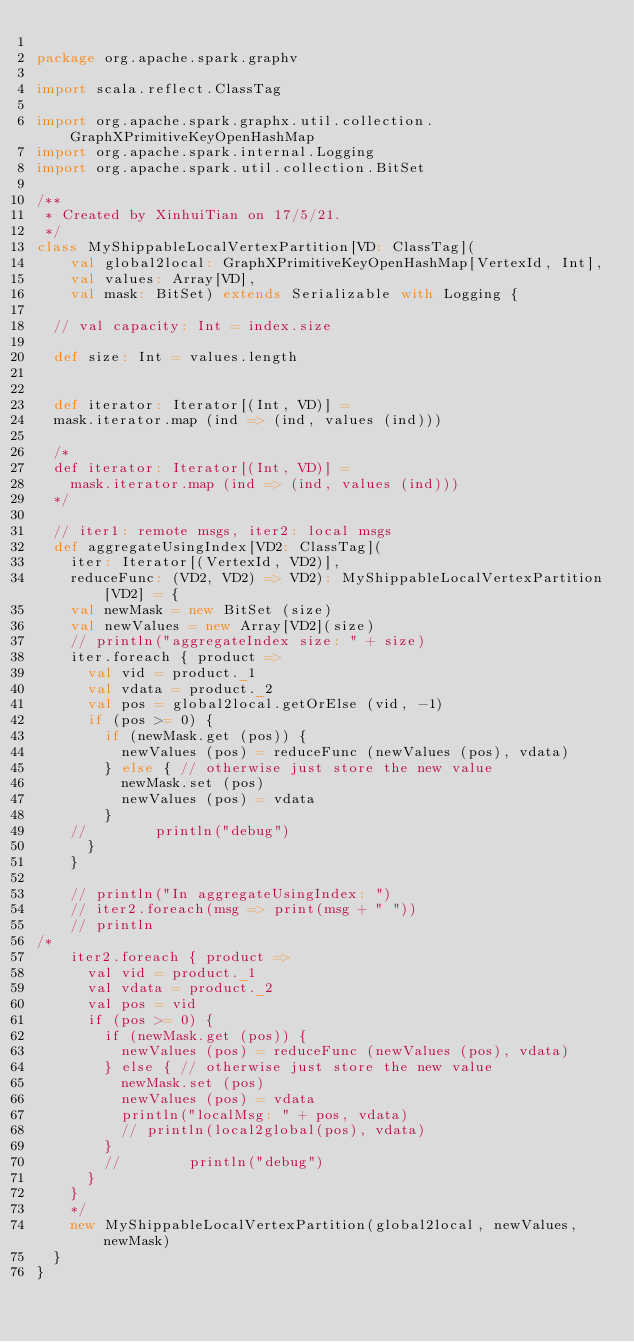Convert code to text. <code><loc_0><loc_0><loc_500><loc_500><_Scala_>
package org.apache.spark.graphv

import scala.reflect.ClassTag

import org.apache.spark.graphx.util.collection.GraphXPrimitiveKeyOpenHashMap
import org.apache.spark.internal.Logging
import org.apache.spark.util.collection.BitSet

/**
 * Created by XinhuiTian on 17/5/21.
 */
class MyShippableLocalVertexPartition[VD: ClassTag](
    val global2local: GraphXPrimitiveKeyOpenHashMap[VertexId, Int],
    val values: Array[VD],
    val mask: BitSet) extends Serializable with Logging {

  // val capacity: Int = index.size

  def size: Int = values.length


  def iterator: Iterator[(Int, VD)] =
  mask.iterator.map (ind => (ind, values (ind)))

  /*
  def iterator: Iterator[(Int, VD)] =
    mask.iterator.map (ind => (ind, values (ind)))
  */

  // iter1: remote msgs, iter2: local msgs
  def aggregateUsingIndex[VD2: ClassTag](
    iter: Iterator[(VertexId, VD2)],
    reduceFunc: (VD2, VD2) => VD2): MyShippableLocalVertexPartition[VD2] = {
    val newMask = new BitSet (size)
    val newValues = new Array[VD2](size)
    // println("aggregateIndex size: " + size)
    iter.foreach { product =>
      val vid = product._1
      val vdata = product._2
      val pos = global2local.getOrElse (vid, -1)
      if (pos >= 0) {
        if (newMask.get (pos)) {
          newValues (pos) = reduceFunc (newValues (pos), vdata)
        } else { // otherwise just store the new value
          newMask.set (pos)
          newValues (pos) = vdata
        }
    //        println("debug")
      }
    }

    // println("In aggregateUsingIndex: ")
    // iter2.foreach(msg => print(msg + " "))
    // println
/*
    iter2.foreach { product =>
      val vid = product._1
      val vdata = product._2
      val pos = vid
      if (pos >= 0) {
        if (newMask.get (pos)) {
          newValues (pos) = reduceFunc (newValues (pos), vdata)
        } else { // otherwise just store the new value
          newMask.set (pos)
          newValues (pos) = vdata
          println("localMsg: " + pos, vdata)
          // println(local2global(pos), vdata)
        }
        //        println("debug")
      }
    }
    */
    new MyShippableLocalVertexPartition(global2local, newValues, newMask)
  }
}
</code> 